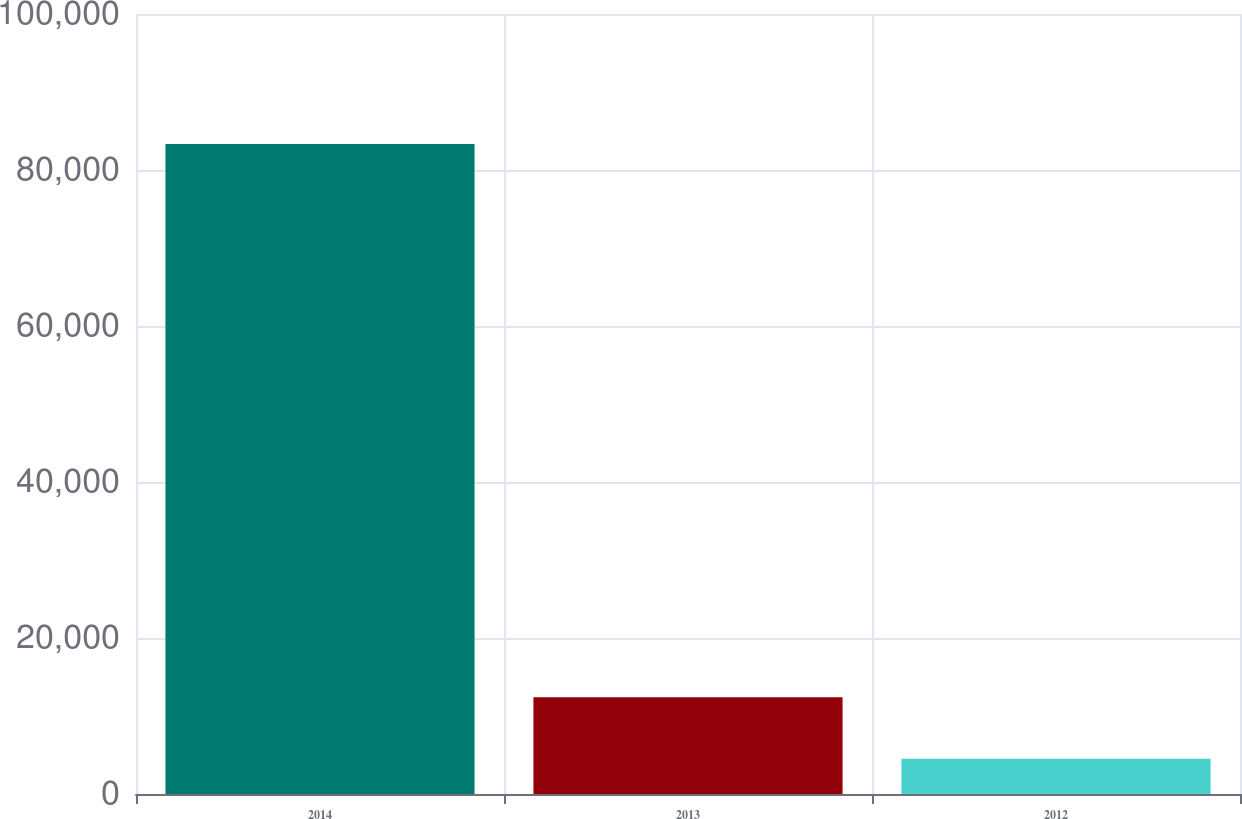Convert chart. <chart><loc_0><loc_0><loc_500><loc_500><bar_chart><fcel>2014<fcel>2013<fcel>2012<nl><fcel>83344<fcel>12404.2<fcel>4522<nl></chart> 